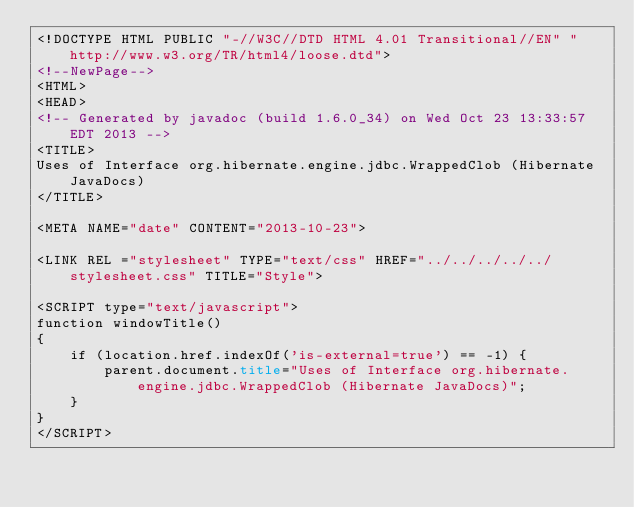<code> <loc_0><loc_0><loc_500><loc_500><_HTML_><!DOCTYPE HTML PUBLIC "-//W3C//DTD HTML 4.01 Transitional//EN" "http://www.w3.org/TR/html4/loose.dtd">
<!--NewPage-->
<HTML>
<HEAD>
<!-- Generated by javadoc (build 1.6.0_34) on Wed Oct 23 13:33:57 EDT 2013 -->
<TITLE>
Uses of Interface org.hibernate.engine.jdbc.WrappedClob (Hibernate JavaDocs)
</TITLE>

<META NAME="date" CONTENT="2013-10-23">

<LINK REL ="stylesheet" TYPE="text/css" HREF="../../../../../stylesheet.css" TITLE="Style">

<SCRIPT type="text/javascript">
function windowTitle()
{
    if (location.href.indexOf('is-external=true') == -1) {
        parent.document.title="Uses of Interface org.hibernate.engine.jdbc.WrappedClob (Hibernate JavaDocs)";
    }
}
</SCRIPT></code> 